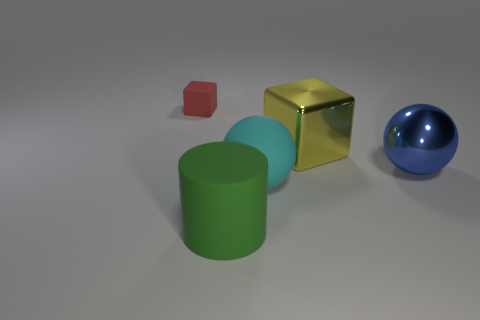Add 4 cyan rubber spheres. How many objects exist? 9 Subtract all blue balls. How many balls are left? 1 Subtract all cyan balls. How many gray cubes are left? 0 Subtract all cyan balls. Subtract all red things. How many objects are left? 3 Add 4 rubber things. How many rubber things are left? 7 Add 4 big yellow metal objects. How many big yellow metal objects exist? 5 Subtract 0 red balls. How many objects are left? 5 Subtract all cylinders. How many objects are left? 4 Subtract all brown blocks. Subtract all brown balls. How many blocks are left? 2 